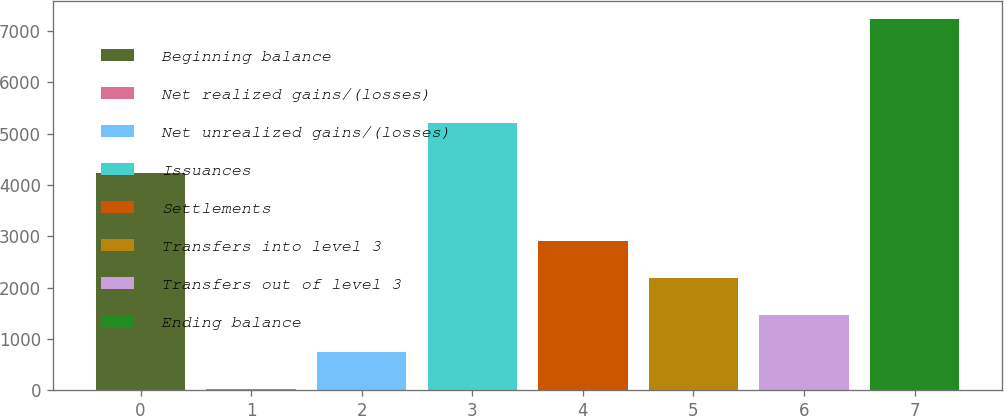Convert chart to OTSL. <chart><loc_0><loc_0><loc_500><loc_500><bar_chart><fcel>Beginning balance<fcel>Net realized gains/(losses)<fcel>Net unrealized gains/(losses)<fcel>Issuances<fcel>Settlements<fcel>Transfers into level 3<fcel>Transfers out of level 3<fcel>Ending balance<nl><fcel>4224<fcel>27<fcel>746.8<fcel>5201<fcel>2906.2<fcel>2186.4<fcel>1466.6<fcel>7225<nl></chart> 